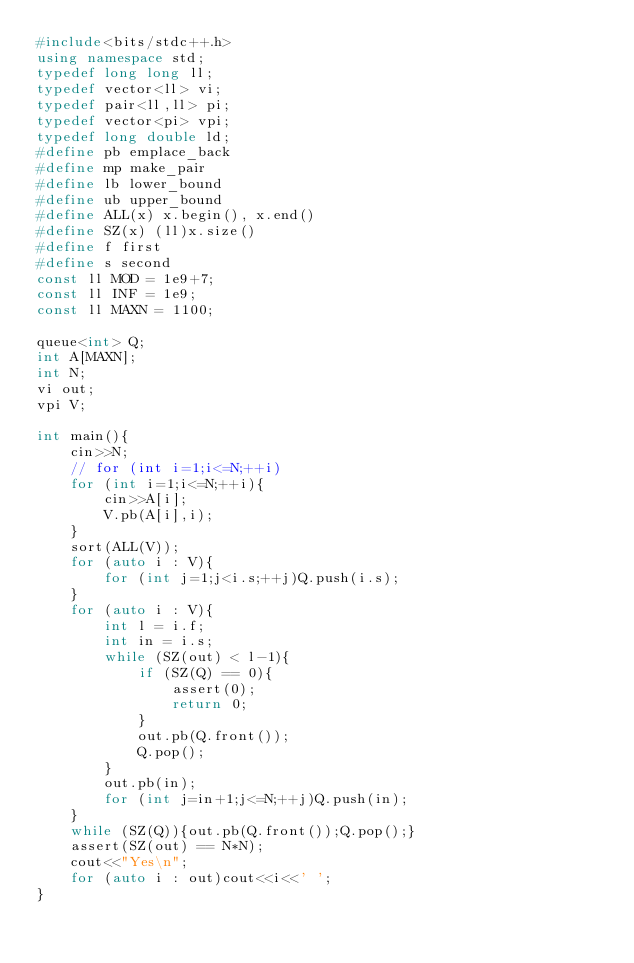Convert code to text. <code><loc_0><loc_0><loc_500><loc_500><_C++_>#include<bits/stdc++.h>
using namespace std;
typedef long long ll;
typedef vector<ll> vi;
typedef pair<ll,ll> pi;
typedef vector<pi> vpi;
typedef long double ld;
#define pb emplace_back
#define mp make_pair
#define lb lower_bound
#define ub upper_bound
#define ALL(x) x.begin(), x.end()
#define SZ(x) (ll)x.size()
#define f first
#define s second
const ll MOD = 1e9+7;
const ll INF = 1e9;
const ll MAXN = 1100;

queue<int> Q;
int A[MAXN];
int N;
vi out;
vpi V;

int main(){
    cin>>N;
    // for (int i=1;i<=N;++i)
    for (int i=1;i<=N;++i){
        cin>>A[i];
        V.pb(A[i],i);
    }
    sort(ALL(V));
    for (auto i : V){
        for (int j=1;j<i.s;++j)Q.push(i.s);
    }
    for (auto i : V){
        int l = i.f;
        int in = i.s;
        while (SZ(out) < l-1){
            if (SZ(Q) == 0){
                assert(0);
                return 0;
            }
            out.pb(Q.front());
            Q.pop();
        }
        out.pb(in);
        for (int j=in+1;j<=N;++j)Q.push(in);
    }
    while (SZ(Q)){out.pb(Q.front());Q.pop();}
    assert(SZ(out) == N*N);
    cout<<"Yes\n";
    for (auto i : out)cout<<i<<' ';
}</code> 